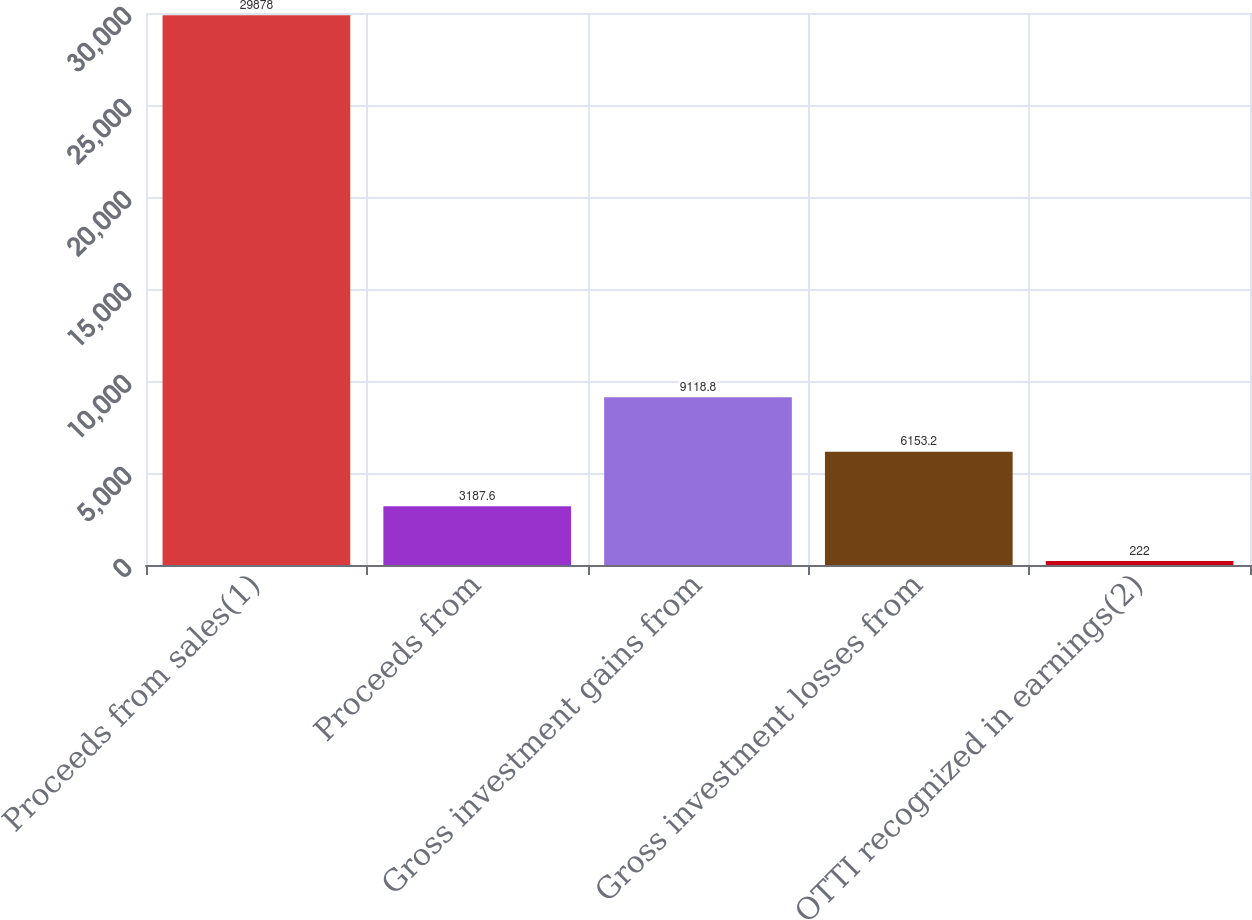Convert chart to OTSL. <chart><loc_0><loc_0><loc_500><loc_500><bar_chart><fcel>Proceeds from sales(1)<fcel>Proceeds from<fcel>Gross investment gains from<fcel>Gross investment losses from<fcel>OTTI recognized in earnings(2)<nl><fcel>29878<fcel>3187.6<fcel>9118.8<fcel>6153.2<fcel>222<nl></chart> 